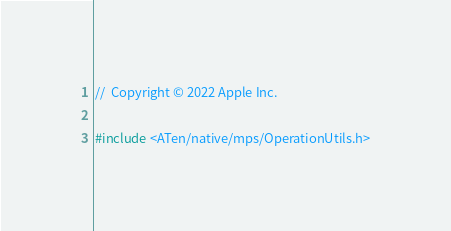<code> <loc_0><loc_0><loc_500><loc_500><_ObjectiveC_>//  Copyright © 2022 Apple Inc.

#include <ATen/native/mps/OperationUtils.h></code> 